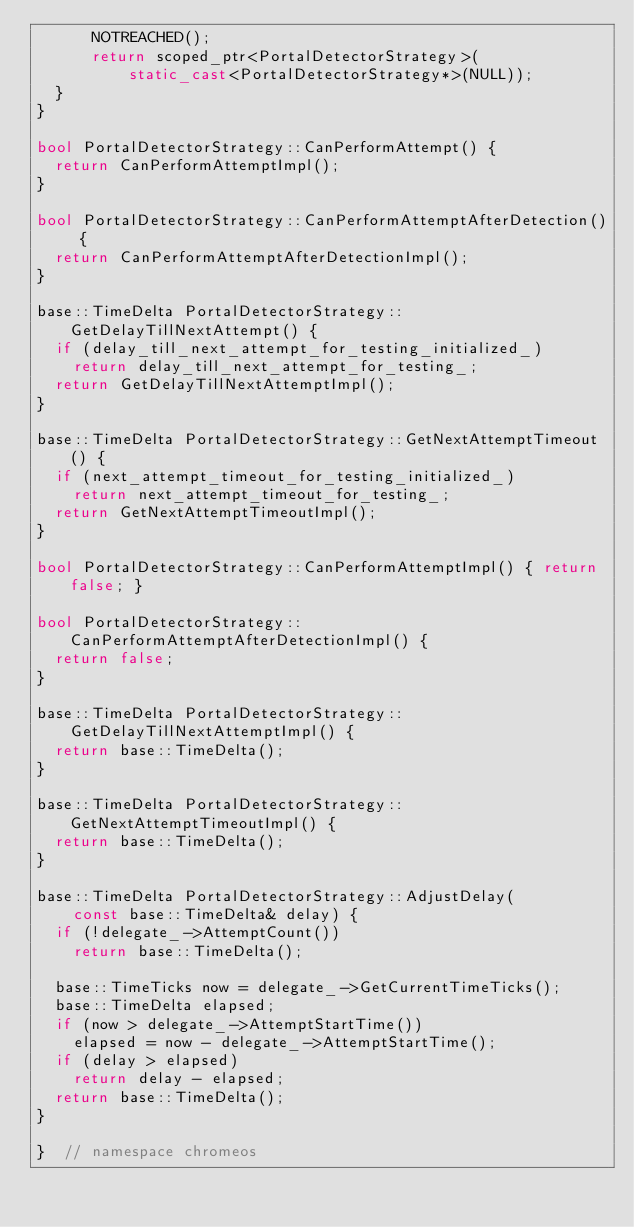Convert code to text. <code><loc_0><loc_0><loc_500><loc_500><_C++_>      NOTREACHED();
      return scoped_ptr<PortalDetectorStrategy>(
          static_cast<PortalDetectorStrategy*>(NULL));
  }
}

bool PortalDetectorStrategy::CanPerformAttempt() {
  return CanPerformAttemptImpl();
}

bool PortalDetectorStrategy::CanPerformAttemptAfterDetection() {
  return CanPerformAttemptAfterDetectionImpl();
}

base::TimeDelta PortalDetectorStrategy::GetDelayTillNextAttempt() {
  if (delay_till_next_attempt_for_testing_initialized_)
    return delay_till_next_attempt_for_testing_;
  return GetDelayTillNextAttemptImpl();
}

base::TimeDelta PortalDetectorStrategy::GetNextAttemptTimeout() {
  if (next_attempt_timeout_for_testing_initialized_)
    return next_attempt_timeout_for_testing_;
  return GetNextAttemptTimeoutImpl();
}

bool PortalDetectorStrategy::CanPerformAttemptImpl() { return false; }

bool PortalDetectorStrategy::CanPerformAttemptAfterDetectionImpl() {
  return false;
}

base::TimeDelta PortalDetectorStrategy::GetDelayTillNextAttemptImpl() {
  return base::TimeDelta();
}

base::TimeDelta PortalDetectorStrategy::GetNextAttemptTimeoutImpl() {
  return base::TimeDelta();
}

base::TimeDelta PortalDetectorStrategy::AdjustDelay(
    const base::TimeDelta& delay) {
  if (!delegate_->AttemptCount())
    return base::TimeDelta();

  base::TimeTicks now = delegate_->GetCurrentTimeTicks();
  base::TimeDelta elapsed;
  if (now > delegate_->AttemptStartTime())
    elapsed = now - delegate_->AttemptStartTime();
  if (delay > elapsed)
    return delay - elapsed;
  return base::TimeDelta();
}

}  // namespace chromeos
</code> 